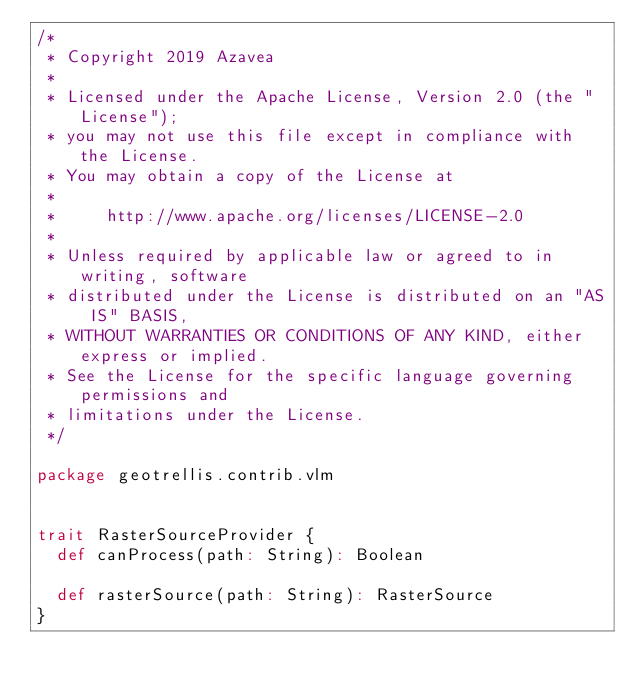Convert code to text. <code><loc_0><loc_0><loc_500><loc_500><_Scala_>/*
 * Copyright 2019 Azavea
 *
 * Licensed under the Apache License, Version 2.0 (the "License");
 * you may not use this file except in compliance with the License.
 * You may obtain a copy of the License at
 *
 *     http://www.apache.org/licenses/LICENSE-2.0
 *
 * Unless required by applicable law or agreed to in writing, software
 * distributed under the License is distributed on an "AS IS" BASIS,
 * WITHOUT WARRANTIES OR CONDITIONS OF ANY KIND, either express or implied.
 * See the License for the specific language governing permissions and
 * limitations under the License.
 */

package geotrellis.contrib.vlm


trait RasterSourceProvider {
  def canProcess(path: String): Boolean

  def rasterSource(path: String): RasterSource
}
</code> 